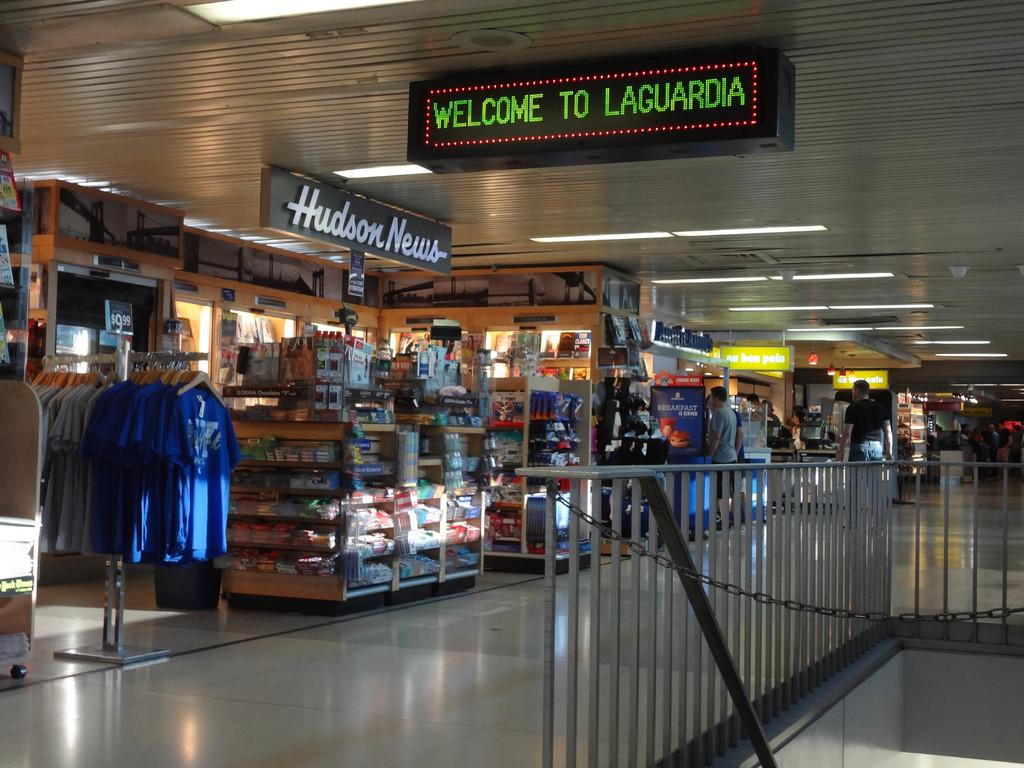<image>
Write a terse but informative summary of the picture. A sign in front of the Hudson News stand welcomes people to Laguardia airport. 